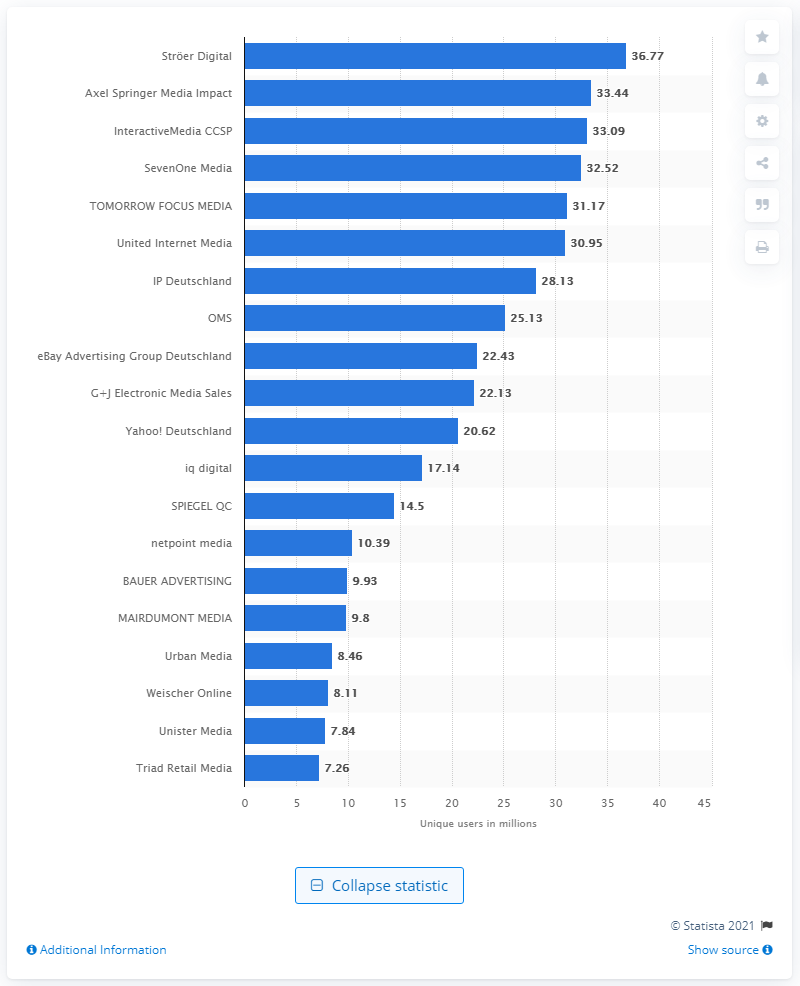Outline some significant characteristics in this image. In May 2015, IP Deutschland had 28,130 unique users. 